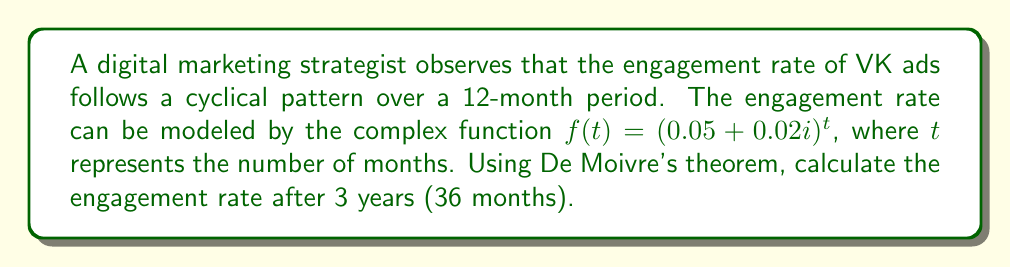Give your solution to this math problem. Let's approach this step-by-step:

1) First, we need to express the complex number in polar form:
   $0.05 + 0.02i = r(\cos\theta + i\sin\theta)$

2) Calculate $r$:
   $r = \sqrt{0.05^2 + 0.02^2} = \sqrt{0.0029} \approx 0.0538$

3) Calculate $\theta$:
   $\theta = \arctan(\frac{0.02}{0.05}) \approx 0.3805$ radians

4) Now we have: $0.05 + 0.02i = 0.0538(\cos(0.3805) + i\sin(0.3805))$

5) Apply De Moivre's theorem: $(r(\cos\theta + i\sin\theta))^n = r^n(\cos(n\theta) + i\sin(n\theta))$

6) In our case, $n = 36$, so:
   $f(36) = 0.0538^{36}(\cos(36 \cdot 0.3805) + i\sin(36 \cdot 0.3805))$

7) Calculate $0.0538^{36}$:
   $0.0538^{36} \approx 1.5477 \times 10^{-46}$

8) Calculate $36 \cdot 0.3805 = 13.698$ radians

9) Therefore:
   $f(36) = (1.5477 \times 10^{-46})(\cos(13.698) + i\sin(13.698))$

10) Evaluate:
    $f(36) \approx (1.5477 \times 10^{-46})(0.1916 + 0.9815i)$

11) Simplify:
    $f(36) \approx 2.9654 \times 10^{-47} + 1.5191 \times 10^{-46}i$
Answer: $2.9654 \times 10^{-47} + 1.5191 \times 10^{-46}i$ 